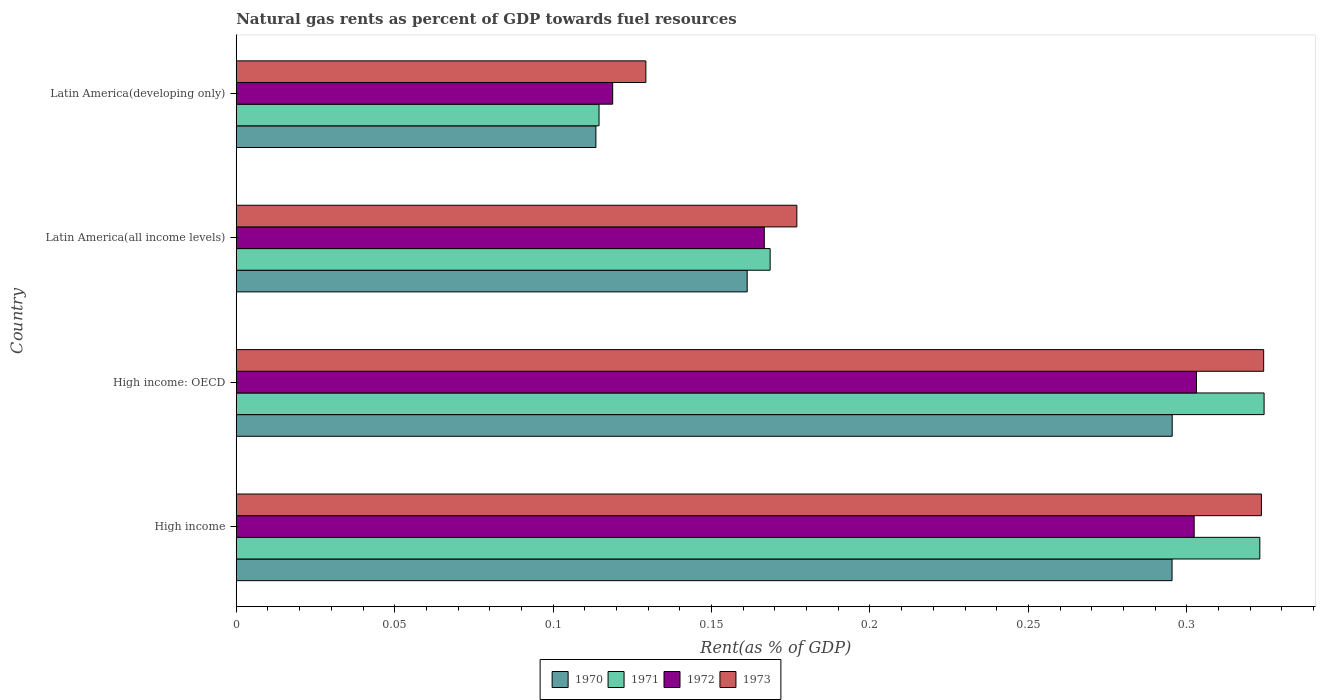How many different coloured bars are there?
Your response must be concise. 4. How many groups of bars are there?
Offer a very short reply. 4. Are the number of bars on each tick of the Y-axis equal?
Provide a short and direct response. Yes. How many bars are there on the 4th tick from the top?
Your response must be concise. 4. How many bars are there on the 3rd tick from the bottom?
Provide a succinct answer. 4. What is the label of the 3rd group of bars from the top?
Your answer should be compact. High income: OECD. What is the matural gas rent in 1973 in Latin America(developing only)?
Your answer should be compact. 0.13. Across all countries, what is the maximum matural gas rent in 1970?
Your response must be concise. 0.3. Across all countries, what is the minimum matural gas rent in 1972?
Provide a short and direct response. 0.12. In which country was the matural gas rent in 1972 maximum?
Offer a terse response. High income: OECD. In which country was the matural gas rent in 1972 minimum?
Offer a very short reply. Latin America(developing only). What is the total matural gas rent in 1972 in the graph?
Your answer should be very brief. 0.89. What is the difference between the matural gas rent in 1970 in Latin America(all income levels) and that in Latin America(developing only)?
Make the answer very short. 0.05. What is the difference between the matural gas rent in 1971 in Latin America(developing only) and the matural gas rent in 1972 in High income: OECD?
Your answer should be very brief. -0.19. What is the average matural gas rent in 1973 per country?
Give a very brief answer. 0.24. What is the difference between the matural gas rent in 1973 and matural gas rent in 1970 in Latin America(developing only)?
Make the answer very short. 0.02. In how many countries, is the matural gas rent in 1971 greater than 0.31000000000000005 %?
Provide a succinct answer. 2. What is the ratio of the matural gas rent in 1973 in Latin America(all income levels) to that in Latin America(developing only)?
Ensure brevity in your answer.  1.37. Is the matural gas rent in 1970 in High income: OECD less than that in Latin America(developing only)?
Your answer should be very brief. No. Is the difference between the matural gas rent in 1973 in High income: OECD and Latin America(all income levels) greater than the difference between the matural gas rent in 1970 in High income: OECD and Latin America(all income levels)?
Provide a short and direct response. Yes. What is the difference between the highest and the second highest matural gas rent in 1970?
Give a very brief answer. 4.502023738700567e-5. What is the difference between the highest and the lowest matural gas rent in 1970?
Your response must be concise. 0.18. Is the sum of the matural gas rent in 1972 in High income and Latin America(all income levels) greater than the maximum matural gas rent in 1971 across all countries?
Your answer should be very brief. Yes. What does the 1st bar from the bottom in High income represents?
Ensure brevity in your answer.  1970. How many bars are there?
Offer a terse response. 16. What is the difference between two consecutive major ticks on the X-axis?
Give a very brief answer. 0.05. Does the graph contain any zero values?
Your answer should be very brief. No. Does the graph contain grids?
Offer a very short reply. No. What is the title of the graph?
Offer a very short reply. Natural gas rents as percent of GDP towards fuel resources. Does "1962" appear as one of the legend labels in the graph?
Provide a short and direct response. No. What is the label or title of the X-axis?
Provide a succinct answer. Rent(as % of GDP). What is the Rent(as % of GDP) of 1970 in High income?
Give a very brief answer. 0.3. What is the Rent(as % of GDP) in 1971 in High income?
Offer a very short reply. 0.32. What is the Rent(as % of GDP) of 1972 in High income?
Your answer should be very brief. 0.3. What is the Rent(as % of GDP) in 1973 in High income?
Offer a very short reply. 0.32. What is the Rent(as % of GDP) of 1970 in High income: OECD?
Your answer should be compact. 0.3. What is the Rent(as % of GDP) of 1971 in High income: OECD?
Your response must be concise. 0.32. What is the Rent(as % of GDP) of 1972 in High income: OECD?
Provide a short and direct response. 0.3. What is the Rent(as % of GDP) of 1973 in High income: OECD?
Provide a succinct answer. 0.32. What is the Rent(as % of GDP) of 1970 in Latin America(all income levels)?
Offer a terse response. 0.16. What is the Rent(as % of GDP) in 1971 in Latin America(all income levels)?
Offer a very short reply. 0.17. What is the Rent(as % of GDP) in 1972 in Latin America(all income levels)?
Provide a succinct answer. 0.17. What is the Rent(as % of GDP) in 1973 in Latin America(all income levels)?
Make the answer very short. 0.18. What is the Rent(as % of GDP) in 1970 in Latin America(developing only)?
Ensure brevity in your answer.  0.11. What is the Rent(as % of GDP) of 1971 in Latin America(developing only)?
Your response must be concise. 0.11. What is the Rent(as % of GDP) in 1972 in Latin America(developing only)?
Offer a very short reply. 0.12. What is the Rent(as % of GDP) in 1973 in Latin America(developing only)?
Provide a succinct answer. 0.13. Across all countries, what is the maximum Rent(as % of GDP) of 1970?
Provide a succinct answer. 0.3. Across all countries, what is the maximum Rent(as % of GDP) of 1971?
Ensure brevity in your answer.  0.32. Across all countries, what is the maximum Rent(as % of GDP) of 1972?
Provide a succinct answer. 0.3. Across all countries, what is the maximum Rent(as % of GDP) in 1973?
Offer a terse response. 0.32. Across all countries, what is the minimum Rent(as % of GDP) in 1970?
Keep it short and to the point. 0.11. Across all countries, what is the minimum Rent(as % of GDP) in 1971?
Your answer should be very brief. 0.11. Across all countries, what is the minimum Rent(as % of GDP) of 1972?
Offer a very short reply. 0.12. Across all countries, what is the minimum Rent(as % of GDP) of 1973?
Provide a short and direct response. 0.13. What is the total Rent(as % of GDP) of 1970 in the graph?
Provide a succinct answer. 0.87. What is the total Rent(as % of GDP) in 1971 in the graph?
Make the answer very short. 0.93. What is the total Rent(as % of GDP) of 1972 in the graph?
Provide a succinct answer. 0.89. What is the total Rent(as % of GDP) in 1973 in the graph?
Your response must be concise. 0.95. What is the difference between the Rent(as % of GDP) in 1971 in High income and that in High income: OECD?
Your answer should be very brief. -0. What is the difference between the Rent(as % of GDP) of 1972 in High income and that in High income: OECD?
Ensure brevity in your answer.  -0. What is the difference between the Rent(as % of GDP) of 1973 in High income and that in High income: OECD?
Your answer should be very brief. -0. What is the difference between the Rent(as % of GDP) in 1970 in High income and that in Latin America(all income levels)?
Provide a short and direct response. 0.13. What is the difference between the Rent(as % of GDP) in 1971 in High income and that in Latin America(all income levels)?
Ensure brevity in your answer.  0.15. What is the difference between the Rent(as % of GDP) in 1972 in High income and that in Latin America(all income levels)?
Your response must be concise. 0.14. What is the difference between the Rent(as % of GDP) of 1973 in High income and that in Latin America(all income levels)?
Give a very brief answer. 0.15. What is the difference between the Rent(as % of GDP) of 1970 in High income and that in Latin America(developing only)?
Make the answer very short. 0.18. What is the difference between the Rent(as % of GDP) in 1971 in High income and that in Latin America(developing only)?
Make the answer very short. 0.21. What is the difference between the Rent(as % of GDP) in 1972 in High income and that in Latin America(developing only)?
Keep it short and to the point. 0.18. What is the difference between the Rent(as % of GDP) of 1973 in High income and that in Latin America(developing only)?
Give a very brief answer. 0.19. What is the difference between the Rent(as % of GDP) in 1970 in High income: OECD and that in Latin America(all income levels)?
Offer a very short reply. 0.13. What is the difference between the Rent(as % of GDP) of 1971 in High income: OECD and that in Latin America(all income levels)?
Offer a very short reply. 0.16. What is the difference between the Rent(as % of GDP) in 1972 in High income: OECD and that in Latin America(all income levels)?
Offer a terse response. 0.14. What is the difference between the Rent(as % of GDP) in 1973 in High income: OECD and that in Latin America(all income levels)?
Give a very brief answer. 0.15. What is the difference between the Rent(as % of GDP) in 1970 in High income: OECD and that in Latin America(developing only)?
Offer a terse response. 0.18. What is the difference between the Rent(as % of GDP) of 1971 in High income: OECD and that in Latin America(developing only)?
Make the answer very short. 0.21. What is the difference between the Rent(as % of GDP) of 1972 in High income: OECD and that in Latin America(developing only)?
Your response must be concise. 0.18. What is the difference between the Rent(as % of GDP) in 1973 in High income: OECD and that in Latin America(developing only)?
Make the answer very short. 0.2. What is the difference between the Rent(as % of GDP) in 1970 in Latin America(all income levels) and that in Latin America(developing only)?
Offer a very short reply. 0.05. What is the difference between the Rent(as % of GDP) in 1971 in Latin America(all income levels) and that in Latin America(developing only)?
Your answer should be very brief. 0.05. What is the difference between the Rent(as % of GDP) in 1972 in Latin America(all income levels) and that in Latin America(developing only)?
Provide a short and direct response. 0.05. What is the difference between the Rent(as % of GDP) of 1973 in Latin America(all income levels) and that in Latin America(developing only)?
Provide a succinct answer. 0.05. What is the difference between the Rent(as % of GDP) in 1970 in High income and the Rent(as % of GDP) in 1971 in High income: OECD?
Provide a succinct answer. -0.03. What is the difference between the Rent(as % of GDP) of 1970 in High income and the Rent(as % of GDP) of 1972 in High income: OECD?
Provide a short and direct response. -0.01. What is the difference between the Rent(as % of GDP) in 1970 in High income and the Rent(as % of GDP) in 1973 in High income: OECD?
Your response must be concise. -0.03. What is the difference between the Rent(as % of GDP) of 1971 in High income and the Rent(as % of GDP) of 1973 in High income: OECD?
Offer a very short reply. -0. What is the difference between the Rent(as % of GDP) of 1972 in High income and the Rent(as % of GDP) of 1973 in High income: OECD?
Make the answer very short. -0.02. What is the difference between the Rent(as % of GDP) in 1970 in High income and the Rent(as % of GDP) in 1971 in Latin America(all income levels)?
Provide a short and direct response. 0.13. What is the difference between the Rent(as % of GDP) of 1970 in High income and the Rent(as % of GDP) of 1972 in Latin America(all income levels)?
Ensure brevity in your answer.  0.13. What is the difference between the Rent(as % of GDP) of 1970 in High income and the Rent(as % of GDP) of 1973 in Latin America(all income levels)?
Keep it short and to the point. 0.12. What is the difference between the Rent(as % of GDP) of 1971 in High income and the Rent(as % of GDP) of 1972 in Latin America(all income levels)?
Make the answer very short. 0.16. What is the difference between the Rent(as % of GDP) in 1971 in High income and the Rent(as % of GDP) in 1973 in Latin America(all income levels)?
Make the answer very short. 0.15. What is the difference between the Rent(as % of GDP) in 1972 in High income and the Rent(as % of GDP) in 1973 in Latin America(all income levels)?
Ensure brevity in your answer.  0.13. What is the difference between the Rent(as % of GDP) of 1970 in High income and the Rent(as % of GDP) of 1971 in Latin America(developing only)?
Your answer should be compact. 0.18. What is the difference between the Rent(as % of GDP) of 1970 in High income and the Rent(as % of GDP) of 1972 in Latin America(developing only)?
Offer a very short reply. 0.18. What is the difference between the Rent(as % of GDP) in 1970 in High income and the Rent(as % of GDP) in 1973 in Latin America(developing only)?
Ensure brevity in your answer.  0.17. What is the difference between the Rent(as % of GDP) in 1971 in High income and the Rent(as % of GDP) in 1972 in Latin America(developing only)?
Your answer should be very brief. 0.2. What is the difference between the Rent(as % of GDP) of 1971 in High income and the Rent(as % of GDP) of 1973 in Latin America(developing only)?
Provide a short and direct response. 0.19. What is the difference between the Rent(as % of GDP) in 1972 in High income and the Rent(as % of GDP) in 1973 in Latin America(developing only)?
Keep it short and to the point. 0.17. What is the difference between the Rent(as % of GDP) of 1970 in High income: OECD and the Rent(as % of GDP) of 1971 in Latin America(all income levels)?
Provide a short and direct response. 0.13. What is the difference between the Rent(as % of GDP) in 1970 in High income: OECD and the Rent(as % of GDP) in 1972 in Latin America(all income levels)?
Your answer should be compact. 0.13. What is the difference between the Rent(as % of GDP) of 1970 in High income: OECD and the Rent(as % of GDP) of 1973 in Latin America(all income levels)?
Give a very brief answer. 0.12. What is the difference between the Rent(as % of GDP) of 1971 in High income: OECD and the Rent(as % of GDP) of 1972 in Latin America(all income levels)?
Offer a very short reply. 0.16. What is the difference between the Rent(as % of GDP) in 1971 in High income: OECD and the Rent(as % of GDP) in 1973 in Latin America(all income levels)?
Your answer should be very brief. 0.15. What is the difference between the Rent(as % of GDP) of 1972 in High income: OECD and the Rent(as % of GDP) of 1973 in Latin America(all income levels)?
Your answer should be very brief. 0.13. What is the difference between the Rent(as % of GDP) of 1970 in High income: OECD and the Rent(as % of GDP) of 1971 in Latin America(developing only)?
Give a very brief answer. 0.18. What is the difference between the Rent(as % of GDP) in 1970 in High income: OECD and the Rent(as % of GDP) in 1972 in Latin America(developing only)?
Keep it short and to the point. 0.18. What is the difference between the Rent(as % of GDP) of 1970 in High income: OECD and the Rent(as % of GDP) of 1973 in Latin America(developing only)?
Keep it short and to the point. 0.17. What is the difference between the Rent(as % of GDP) of 1971 in High income: OECD and the Rent(as % of GDP) of 1972 in Latin America(developing only)?
Keep it short and to the point. 0.21. What is the difference between the Rent(as % of GDP) of 1971 in High income: OECD and the Rent(as % of GDP) of 1973 in Latin America(developing only)?
Give a very brief answer. 0.2. What is the difference between the Rent(as % of GDP) in 1972 in High income: OECD and the Rent(as % of GDP) in 1973 in Latin America(developing only)?
Offer a very short reply. 0.17. What is the difference between the Rent(as % of GDP) in 1970 in Latin America(all income levels) and the Rent(as % of GDP) in 1971 in Latin America(developing only)?
Offer a terse response. 0.05. What is the difference between the Rent(as % of GDP) of 1970 in Latin America(all income levels) and the Rent(as % of GDP) of 1972 in Latin America(developing only)?
Give a very brief answer. 0.04. What is the difference between the Rent(as % of GDP) of 1970 in Latin America(all income levels) and the Rent(as % of GDP) of 1973 in Latin America(developing only)?
Give a very brief answer. 0.03. What is the difference between the Rent(as % of GDP) of 1971 in Latin America(all income levels) and the Rent(as % of GDP) of 1972 in Latin America(developing only)?
Provide a short and direct response. 0.05. What is the difference between the Rent(as % of GDP) in 1971 in Latin America(all income levels) and the Rent(as % of GDP) in 1973 in Latin America(developing only)?
Offer a very short reply. 0.04. What is the difference between the Rent(as % of GDP) of 1972 in Latin America(all income levels) and the Rent(as % of GDP) of 1973 in Latin America(developing only)?
Offer a terse response. 0.04. What is the average Rent(as % of GDP) of 1970 per country?
Your response must be concise. 0.22. What is the average Rent(as % of GDP) in 1971 per country?
Provide a short and direct response. 0.23. What is the average Rent(as % of GDP) of 1972 per country?
Provide a succinct answer. 0.22. What is the average Rent(as % of GDP) in 1973 per country?
Give a very brief answer. 0.24. What is the difference between the Rent(as % of GDP) in 1970 and Rent(as % of GDP) in 1971 in High income?
Your response must be concise. -0.03. What is the difference between the Rent(as % of GDP) of 1970 and Rent(as % of GDP) of 1972 in High income?
Ensure brevity in your answer.  -0.01. What is the difference between the Rent(as % of GDP) of 1970 and Rent(as % of GDP) of 1973 in High income?
Provide a short and direct response. -0.03. What is the difference between the Rent(as % of GDP) of 1971 and Rent(as % of GDP) of 1972 in High income?
Give a very brief answer. 0.02. What is the difference between the Rent(as % of GDP) in 1971 and Rent(as % of GDP) in 1973 in High income?
Offer a terse response. -0. What is the difference between the Rent(as % of GDP) of 1972 and Rent(as % of GDP) of 1973 in High income?
Offer a terse response. -0.02. What is the difference between the Rent(as % of GDP) in 1970 and Rent(as % of GDP) in 1971 in High income: OECD?
Offer a terse response. -0.03. What is the difference between the Rent(as % of GDP) of 1970 and Rent(as % of GDP) of 1972 in High income: OECD?
Ensure brevity in your answer.  -0.01. What is the difference between the Rent(as % of GDP) in 1970 and Rent(as % of GDP) in 1973 in High income: OECD?
Offer a very short reply. -0.03. What is the difference between the Rent(as % of GDP) in 1971 and Rent(as % of GDP) in 1972 in High income: OECD?
Make the answer very short. 0.02. What is the difference between the Rent(as % of GDP) of 1972 and Rent(as % of GDP) of 1973 in High income: OECD?
Provide a succinct answer. -0.02. What is the difference between the Rent(as % of GDP) of 1970 and Rent(as % of GDP) of 1971 in Latin America(all income levels)?
Your answer should be compact. -0.01. What is the difference between the Rent(as % of GDP) of 1970 and Rent(as % of GDP) of 1972 in Latin America(all income levels)?
Provide a succinct answer. -0.01. What is the difference between the Rent(as % of GDP) in 1970 and Rent(as % of GDP) in 1973 in Latin America(all income levels)?
Your answer should be very brief. -0.02. What is the difference between the Rent(as % of GDP) in 1971 and Rent(as % of GDP) in 1972 in Latin America(all income levels)?
Keep it short and to the point. 0. What is the difference between the Rent(as % of GDP) of 1971 and Rent(as % of GDP) of 1973 in Latin America(all income levels)?
Your answer should be compact. -0.01. What is the difference between the Rent(as % of GDP) in 1972 and Rent(as % of GDP) in 1973 in Latin America(all income levels)?
Keep it short and to the point. -0.01. What is the difference between the Rent(as % of GDP) of 1970 and Rent(as % of GDP) of 1971 in Latin America(developing only)?
Ensure brevity in your answer.  -0. What is the difference between the Rent(as % of GDP) in 1970 and Rent(as % of GDP) in 1972 in Latin America(developing only)?
Make the answer very short. -0.01. What is the difference between the Rent(as % of GDP) of 1970 and Rent(as % of GDP) of 1973 in Latin America(developing only)?
Provide a short and direct response. -0.02. What is the difference between the Rent(as % of GDP) in 1971 and Rent(as % of GDP) in 1972 in Latin America(developing only)?
Offer a terse response. -0. What is the difference between the Rent(as % of GDP) of 1971 and Rent(as % of GDP) of 1973 in Latin America(developing only)?
Provide a short and direct response. -0.01. What is the difference between the Rent(as % of GDP) of 1972 and Rent(as % of GDP) of 1973 in Latin America(developing only)?
Make the answer very short. -0.01. What is the ratio of the Rent(as % of GDP) in 1970 in High income to that in High income: OECD?
Ensure brevity in your answer.  1. What is the ratio of the Rent(as % of GDP) of 1972 in High income to that in High income: OECD?
Give a very brief answer. 1. What is the ratio of the Rent(as % of GDP) of 1973 in High income to that in High income: OECD?
Your response must be concise. 1. What is the ratio of the Rent(as % of GDP) in 1970 in High income to that in Latin America(all income levels)?
Make the answer very short. 1.83. What is the ratio of the Rent(as % of GDP) in 1971 in High income to that in Latin America(all income levels)?
Your response must be concise. 1.92. What is the ratio of the Rent(as % of GDP) of 1972 in High income to that in Latin America(all income levels)?
Provide a short and direct response. 1.81. What is the ratio of the Rent(as % of GDP) in 1973 in High income to that in Latin America(all income levels)?
Make the answer very short. 1.83. What is the ratio of the Rent(as % of GDP) in 1970 in High income to that in Latin America(developing only)?
Keep it short and to the point. 2.6. What is the ratio of the Rent(as % of GDP) in 1971 in High income to that in Latin America(developing only)?
Your answer should be compact. 2.82. What is the ratio of the Rent(as % of GDP) of 1972 in High income to that in Latin America(developing only)?
Your response must be concise. 2.54. What is the ratio of the Rent(as % of GDP) of 1973 in High income to that in Latin America(developing only)?
Provide a succinct answer. 2.5. What is the ratio of the Rent(as % of GDP) in 1970 in High income: OECD to that in Latin America(all income levels)?
Ensure brevity in your answer.  1.83. What is the ratio of the Rent(as % of GDP) in 1971 in High income: OECD to that in Latin America(all income levels)?
Offer a terse response. 1.93. What is the ratio of the Rent(as % of GDP) of 1972 in High income: OECD to that in Latin America(all income levels)?
Offer a terse response. 1.82. What is the ratio of the Rent(as % of GDP) in 1973 in High income: OECD to that in Latin America(all income levels)?
Your response must be concise. 1.83. What is the ratio of the Rent(as % of GDP) in 1970 in High income: OECD to that in Latin America(developing only)?
Provide a succinct answer. 2.6. What is the ratio of the Rent(as % of GDP) of 1971 in High income: OECD to that in Latin America(developing only)?
Your response must be concise. 2.83. What is the ratio of the Rent(as % of GDP) of 1972 in High income: OECD to that in Latin America(developing only)?
Your answer should be compact. 2.55. What is the ratio of the Rent(as % of GDP) in 1973 in High income: OECD to that in Latin America(developing only)?
Ensure brevity in your answer.  2.51. What is the ratio of the Rent(as % of GDP) in 1970 in Latin America(all income levels) to that in Latin America(developing only)?
Provide a succinct answer. 1.42. What is the ratio of the Rent(as % of GDP) in 1971 in Latin America(all income levels) to that in Latin America(developing only)?
Offer a very short reply. 1.47. What is the ratio of the Rent(as % of GDP) of 1972 in Latin America(all income levels) to that in Latin America(developing only)?
Ensure brevity in your answer.  1.4. What is the ratio of the Rent(as % of GDP) of 1973 in Latin America(all income levels) to that in Latin America(developing only)?
Offer a terse response. 1.37. What is the difference between the highest and the second highest Rent(as % of GDP) of 1970?
Provide a succinct answer. 0. What is the difference between the highest and the second highest Rent(as % of GDP) in 1971?
Offer a terse response. 0. What is the difference between the highest and the second highest Rent(as % of GDP) in 1972?
Your response must be concise. 0. What is the difference between the highest and the second highest Rent(as % of GDP) in 1973?
Offer a terse response. 0. What is the difference between the highest and the lowest Rent(as % of GDP) in 1970?
Make the answer very short. 0.18. What is the difference between the highest and the lowest Rent(as % of GDP) of 1971?
Your answer should be very brief. 0.21. What is the difference between the highest and the lowest Rent(as % of GDP) of 1972?
Your answer should be very brief. 0.18. What is the difference between the highest and the lowest Rent(as % of GDP) of 1973?
Give a very brief answer. 0.2. 